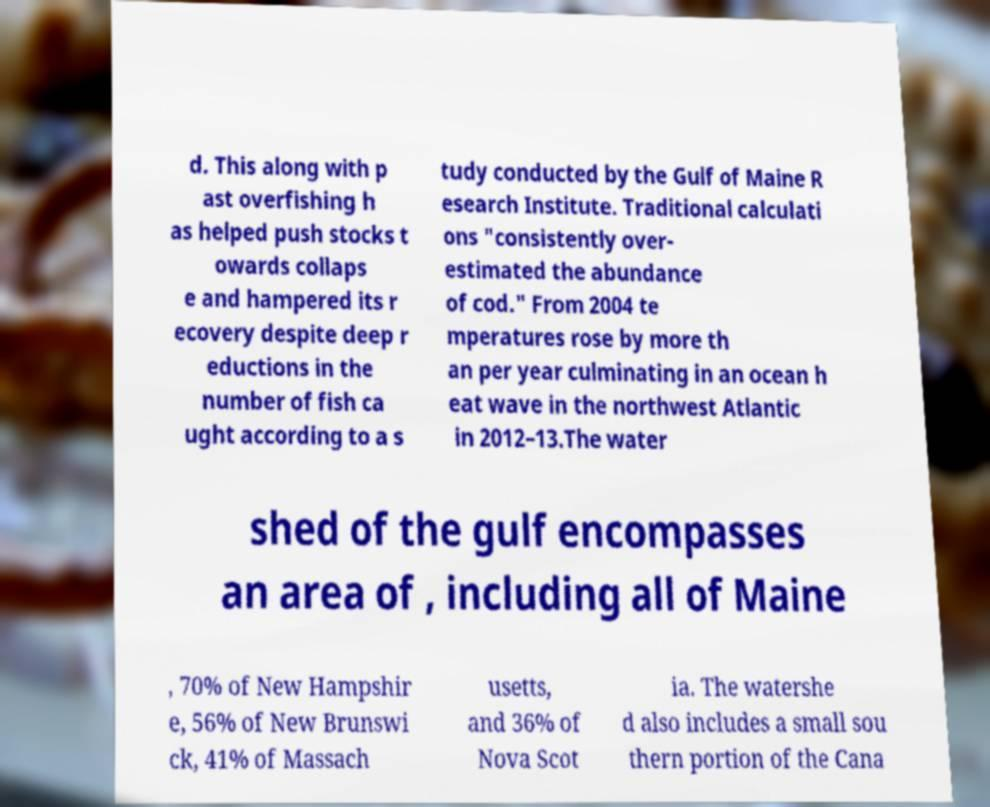For documentation purposes, I need the text within this image transcribed. Could you provide that? d. This along with p ast overfishing h as helped push stocks t owards collaps e and hampered its r ecovery despite deep r eductions in the number of fish ca ught according to a s tudy conducted by the Gulf of Maine R esearch Institute. Traditional calculati ons "consistently over- estimated the abundance of cod." From 2004 te mperatures rose by more th an per year culminating in an ocean h eat wave in the northwest Atlantic in 2012–13.The water shed of the gulf encompasses an area of , including all of Maine , 70% of New Hampshir e, 56% of New Brunswi ck, 41% of Massach usetts, and 36% of Nova Scot ia. The watershe d also includes a small sou thern portion of the Cana 